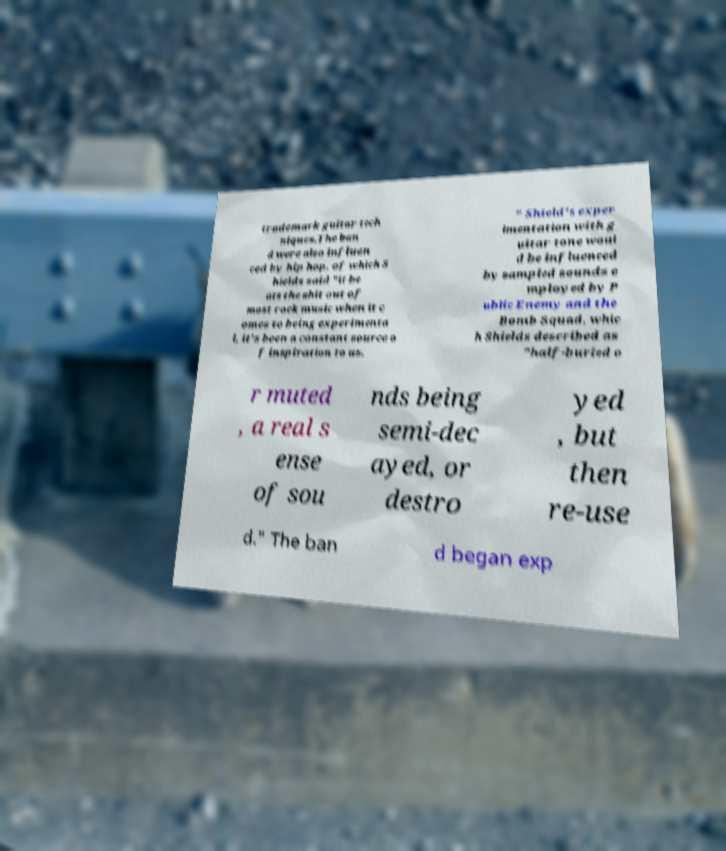For documentation purposes, I need the text within this image transcribed. Could you provide that? trademark guitar tech niques.The ban d were also influen ced by hip hop, of which S hields said "it be ats the shit out of most rock music when it c omes to being experimenta l, it's been a constant source o f inspiration to us. " Shield's exper imentation with g uitar tone woul d be influenced by sampled sounds e mployed by P ublic Enemy and the Bomb Squad, whic h Shields described as "half-buried o r muted , a real s ense of sou nds being semi-dec ayed, or destro yed , but then re-use d." The ban d began exp 